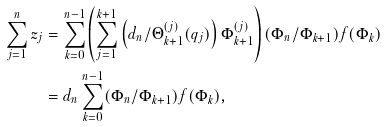Convert formula to latex. <formula><loc_0><loc_0><loc_500><loc_500>\sum _ { j = 1 } ^ { n } z _ { j } & = \sum _ { k = 0 } ^ { n - 1 } \left ( \sum _ { j = 1 } ^ { k + 1 } \left ( d _ { n } / \Theta _ { k + 1 } ^ { ( j ) } ( q _ { j } ) \right ) \Phi _ { k + 1 } ^ { ( j ) } \right ) ( \Phi _ { n } / \Phi _ { k + 1 } ) f ( \Phi _ { k } ) \\ & = d _ { n } \sum _ { k = 0 } ^ { n - 1 } ( \Phi _ { n } / \Phi _ { k + 1 } ) f ( \Phi _ { k } ) ,</formula> 